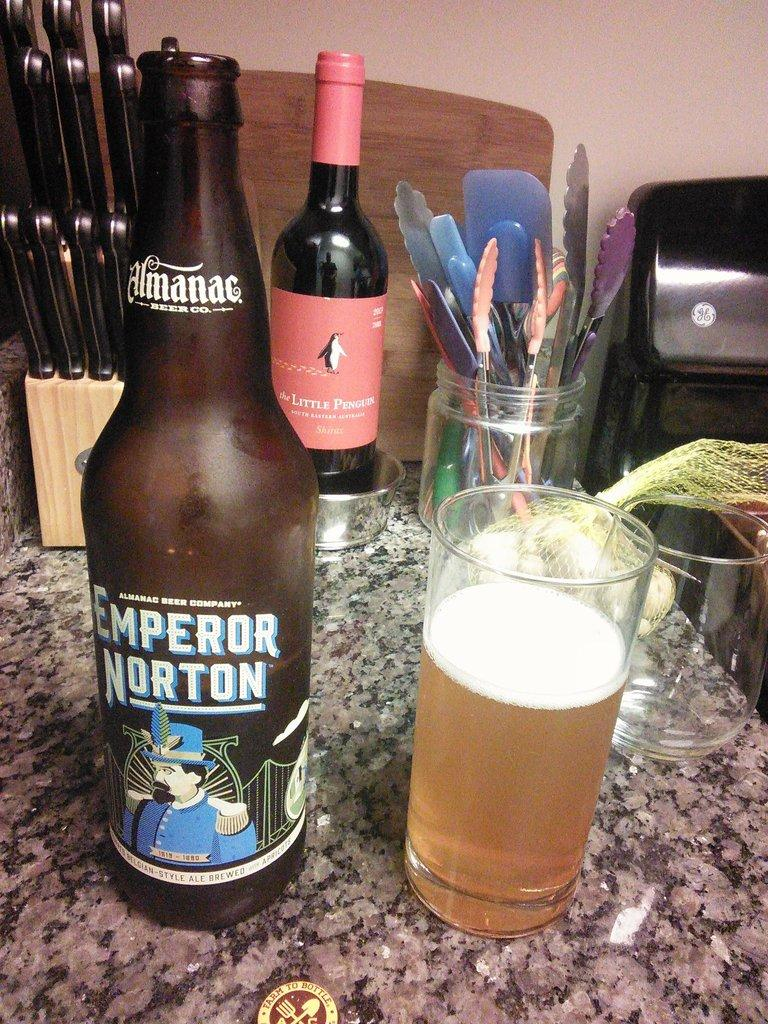How many bottles are visible in the image? There are two bottles in the image. What is in the glass that is visible in the image? There is a drink in the glass. Where is the knife stand located in the image? The knife stand is on the left side of the image. What is inside the jar that is visible in the image? The jar contains kitchen tools. What material is the surface on which the objects are placed? The objects are placed on a marble stone. What type of carpenter is featured in the image? There is no carpenter present in the image. What liquid is being poured into the jar in the image? There is no liquid being poured into the jar in the image; the jar already contains kitchen tools. 